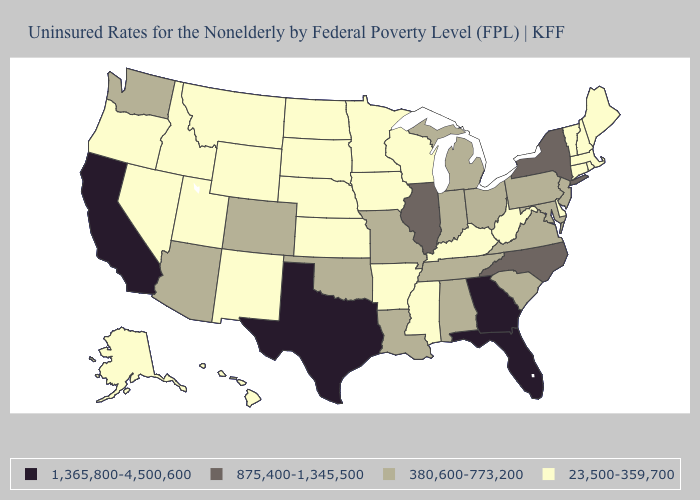Does Pennsylvania have the lowest value in the Northeast?
Answer briefly. No. What is the value of Florida?
Quick response, please. 1,365,800-4,500,600. What is the value of California?
Concise answer only. 1,365,800-4,500,600. Among the states that border Minnesota , which have the highest value?
Be succinct. Iowa, North Dakota, South Dakota, Wisconsin. Among the states that border Arkansas , which have the lowest value?
Concise answer only. Mississippi. What is the value of Nevada?
Answer briefly. 23,500-359,700. What is the lowest value in the USA?
Answer briefly. 23,500-359,700. What is the value of California?
Keep it brief. 1,365,800-4,500,600. Name the states that have a value in the range 380,600-773,200?
Be succinct. Alabama, Arizona, Colorado, Indiana, Louisiana, Maryland, Michigan, Missouri, New Jersey, Ohio, Oklahoma, Pennsylvania, South Carolina, Tennessee, Virginia, Washington. Name the states that have a value in the range 380,600-773,200?
Write a very short answer. Alabama, Arizona, Colorado, Indiana, Louisiana, Maryland, Michigan, Missouri, New Jersey, Ohio, Oklahoma, Pennsylvania, South Carolina, Tennessee, Virginia, Washington. Among the states that border Connecticut , which have the highest value?
Write a very short answer. New York. What is the lowest value in the USA?
Concise answer only. 23,500-359,700. Which states have the lowest value in the USA?
Quick response, please. Alaska, Arkansas, Connecticut, Delaware, Hawaii, Idaho, Iowa, Kansas, Kentucky, Maine, Massachusetts, Minnesota, Mississippi, Montana, Nebraska, Nevada, New Hampshire, New Mexico, North Dakota, Oregon, Rhode Island, South Dakota, Utah, Vermont, West Virginia, Wisconsin, Wyoming. Name the states that have a value in the range 875,400-1,345,500?
Answer briefly. Illinois, New York, North Carolina. 